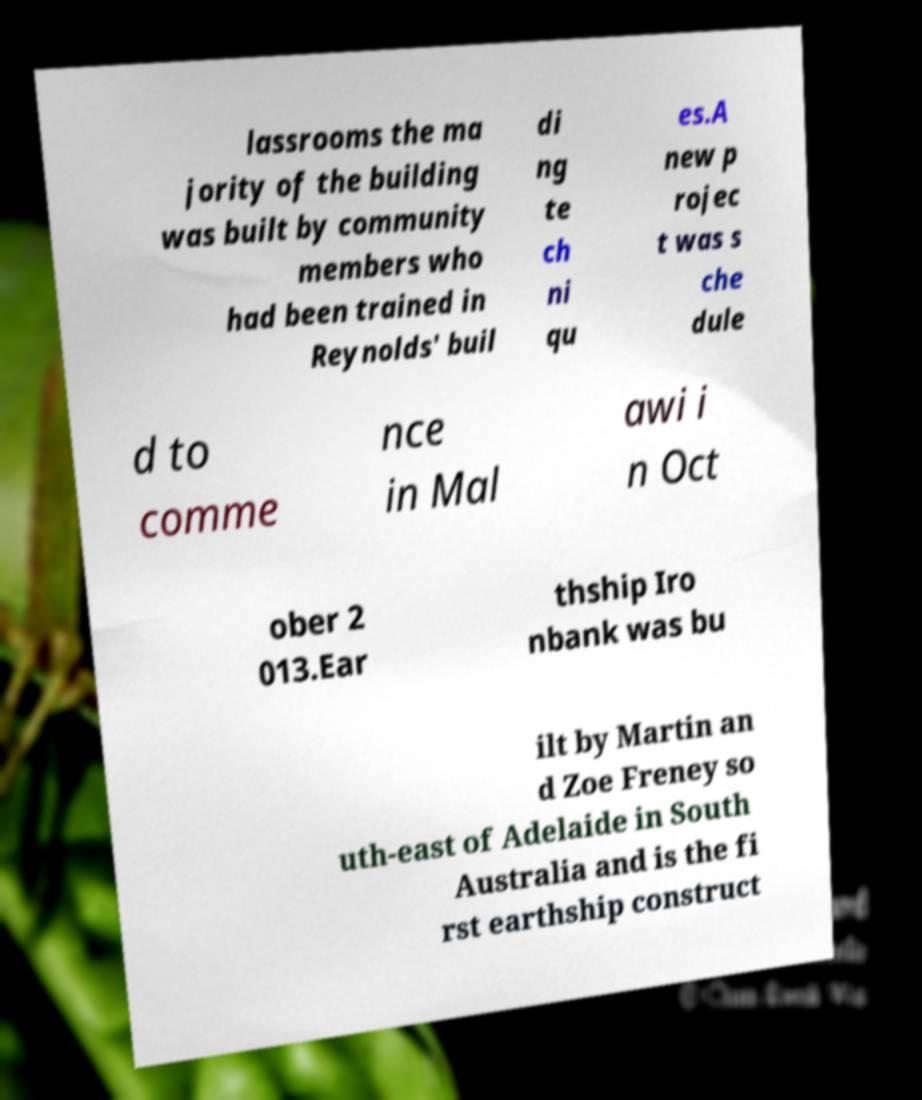For documentation purposes, I need the text within this image transcribed. Could you provide that? lassrooms the ma jority of the building was built by community members who had been trained in Reynolds' buil di ng te ch ni qu es.A new p rojec t was s che dule d to comme nce in Mal awi i n Oct ober 2 013.Ear thship Iro nbank was bu ilt by Martin an d Zoe Freney so uth-east of Adelaide in South Australia and is the fi rst earthship construct 